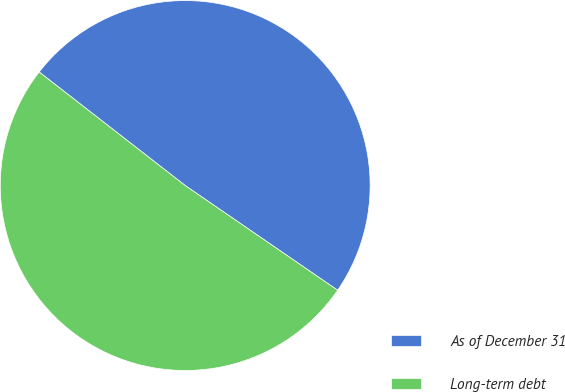Convert chart to OTSL. <chart><loc_0><loc_0><loc_500><loc_500><pie_chart><fcel>As of December 31<fcel>Long-term debt<nl><fcel>49.06%<fcel>50.94%<nl></chart> 